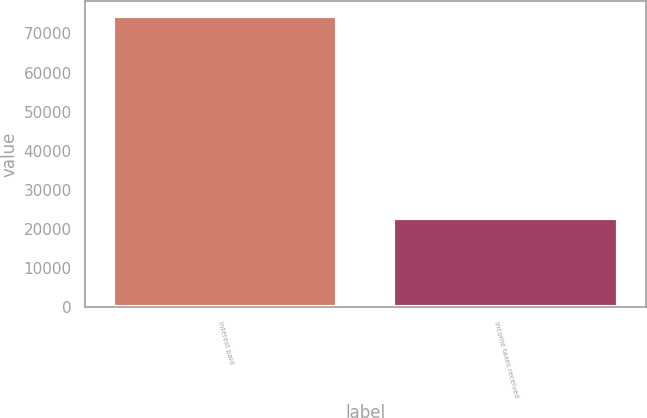<chart> <loc_0><loc_0><loc_500><loc_500><bar_chart><fcel>Interest paid<fcel>Income taxes received<nl><fcel>74569<fcel>22893<nl></chart> 